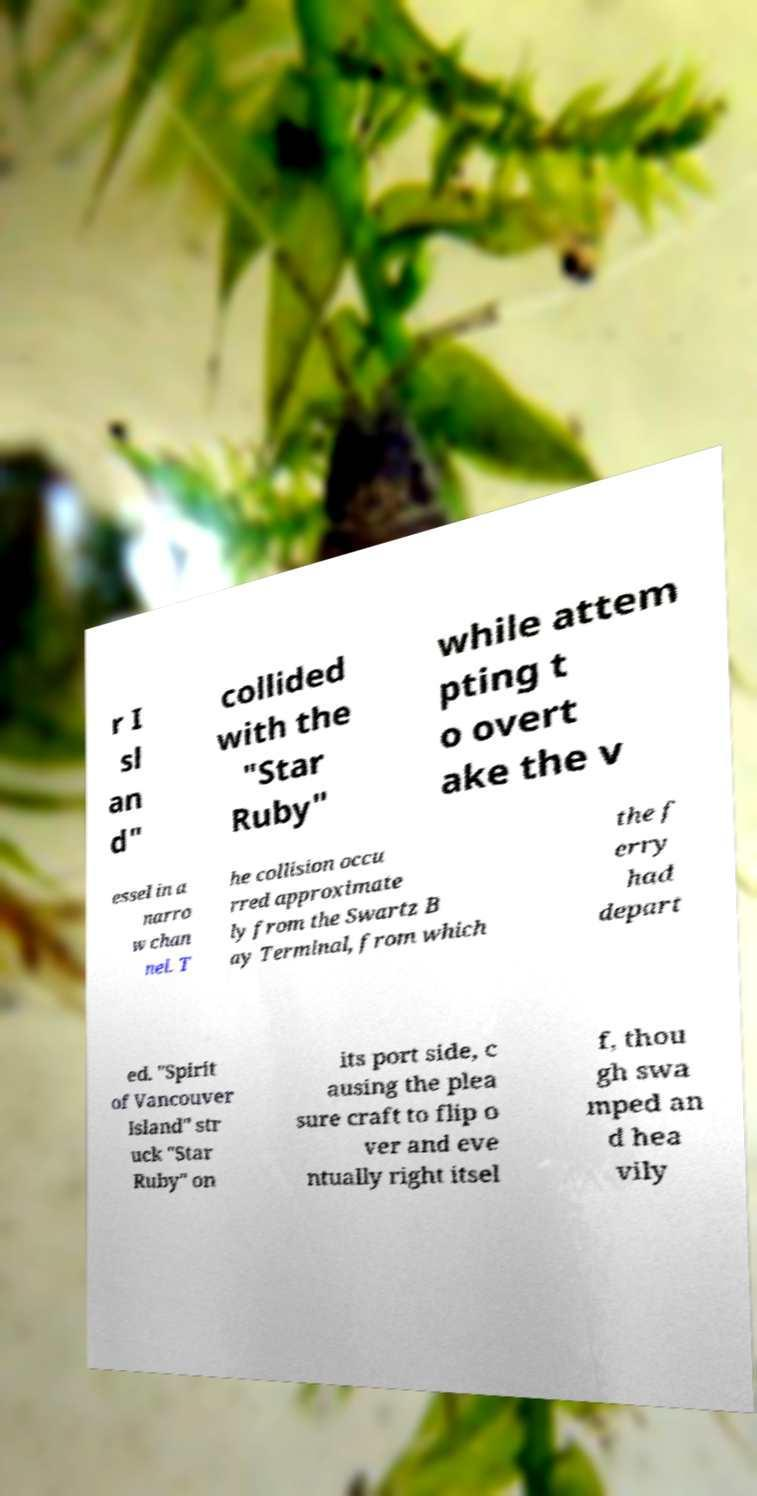For documentation purposes, I need the text within this image transcribed. Could you provide that? r I sl an d" collided with the "Star Ruby" while attem pting t o overt ake the v essel in a narro w chan nel. T he collision occu rred approximate ly from the Swartz B ay Terminal, from which the f erry had depart ed. "Spirit of Vancouver Island" str uck "Star Ruby" on its port side, c ausing the plea sure craft to flip o ver and eve ntually right itsel f, thou gh swa mped an d hea vily 